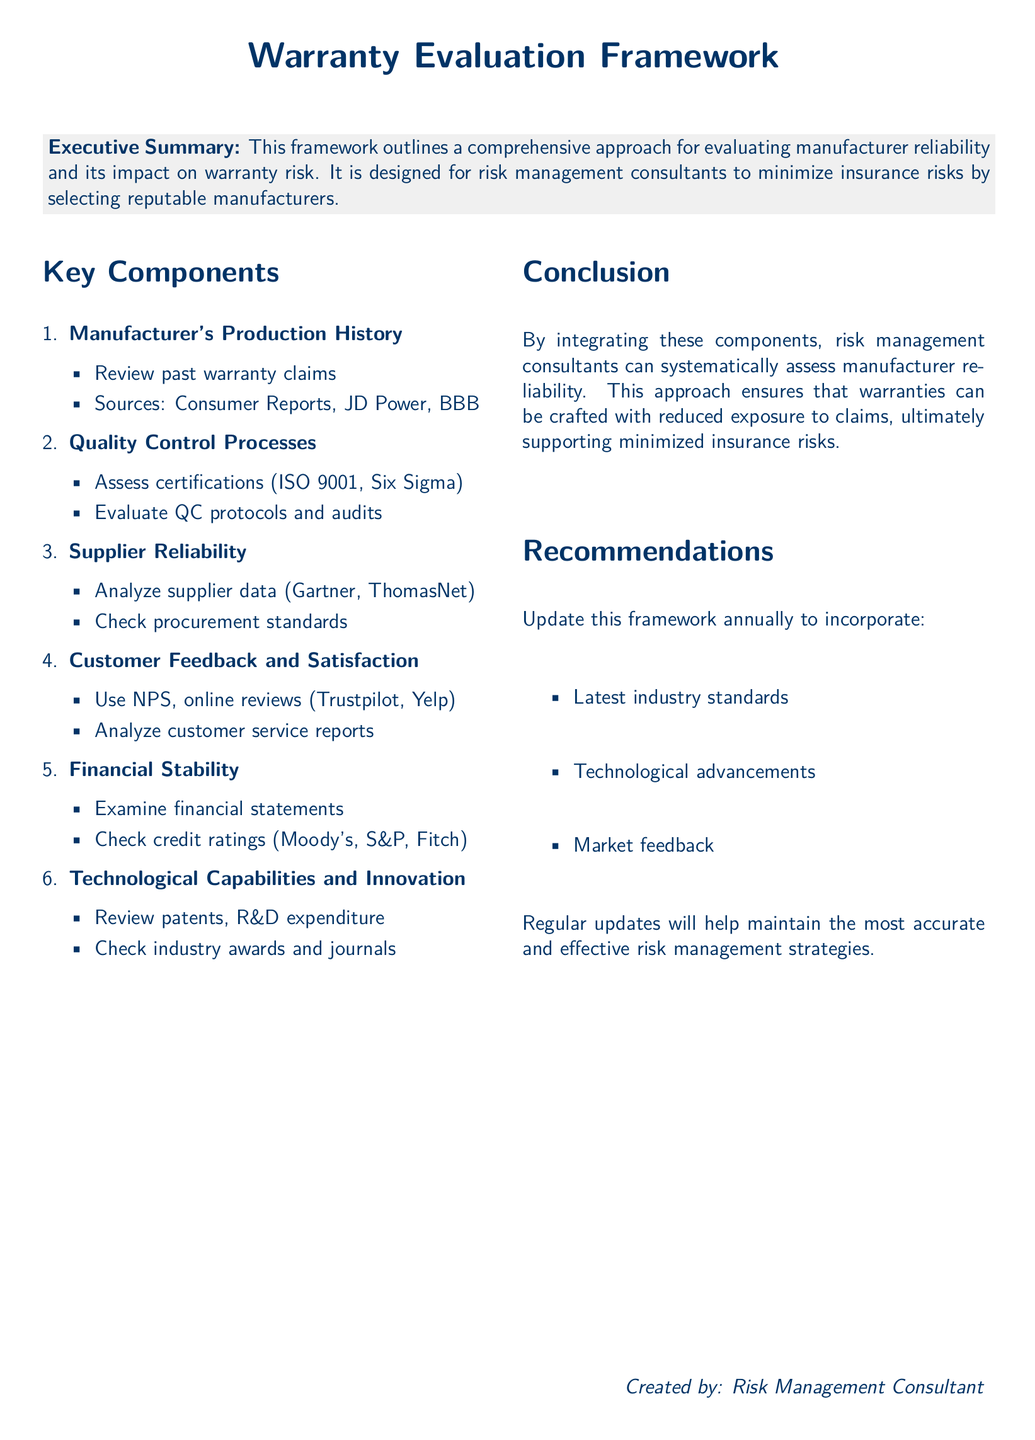what is the title of the document? The title is prominently displayed in the upper section of the document.
Answer: Warranty Evaluation Framework who created this document? The creator is mentioned in the footer of the document.
Answer: Risk Management Consultant how many key components are listed in the document? The number of components can be found in the enumeration section.
Answer: Six what certification is mentioned under Quality Control Processes? The certification is stated explicitly in the section.
Answer: ISO 9001 which financial metrics should be examined according to the document? The metrics related to financial stability are specifically outlined in the document.
Answer: Financial statements what does NPS stand for in the context of Customer Feedback? The abbreviation is part of the description in the Customer Feedback section.
Answer: Net Promoter Score what should be updated annually according to the recommendations? The document clearly specifies what should be updated.
Answer: This framework what type of customer feedback platforms are suggested for evaluation? The suggestions for customer feedback sources are explicitly listed.
Answer: Trustpilot, Yelp what is the focus of this framework? The main purpose of the framework is stated in the Executive Summary.
Answer: Evaluating manufacturer reliability 